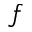<formula> <loc_0><loc_0><loc_500><loc_500>f</formula> 